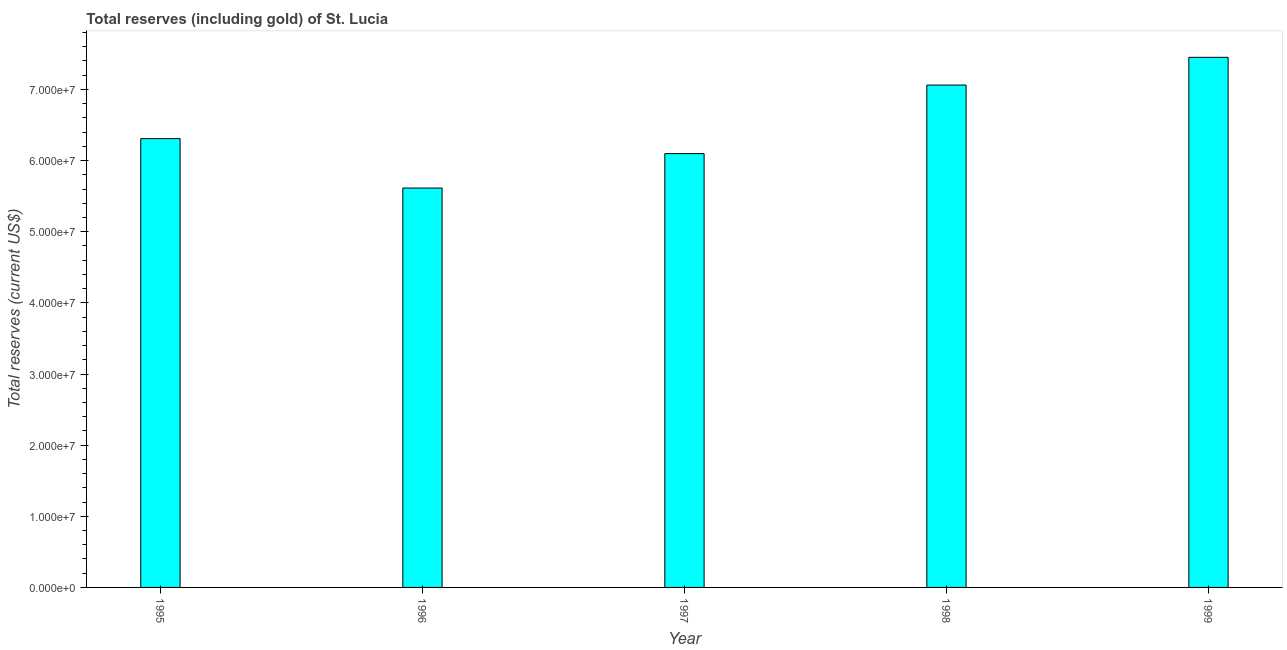Does the graph contain grids?
Provide a short and direct response. No. What is the title of the graph?
Give a very brief answer. Total reserves (including gold) of St. Lucia. What is the label or title of the X-axis?
Keep it short and to the point. Year. What is the label or title of the Y-axis?
Your answer should be very brief. Total reserves (current US$). What is the total reserves (including gold) in 1997?
Offer a very short reply. 6.10e+07. Across all years, what is the maximum total reserves (including gold)?
Your answer should be very brief. 7.45e+07. Across all years, what is the minimum total reserves (including gold)?
Ensure brevity in your answer.  5.61e+07. In which year was the total reserves (including gold) maximum?
Provide a succinct answer. 1999. In which year was the total reserves (including gold) minimum?
Provide a short and direct response. 1996. What is the sum of the total reserves (including gold)?
Your response must be concise. 3.25e+08. What is the difference between the total reserves (including gold) in 1996 and 1997?
Make the answer very short. -4.84e+06. What is the average total reserves (including gold) per year?
Your answer should be very brief. 6.51e+07. What is the median total reserves (including gold)?
Give a very brief answer. 6.31e+07. Do a majority of the years between 1995 and 1997 (inclusive) have total reserves (including gold) greater than 44000000 US$?
Offer a terse response. Yes. What is the ratio of the total reserves (including gold) in 1997 to that in 1998?
Your answer should be compact. 0.86. Is the total reserves (including gold) in 1998 less than that in 1999?
Give a very brief answer. Yes. What is the difference between the highest and the second highest total reserves (including gold)?
Your answer should be compact. 3.90e+06. What is the difference between the highest and the lowest total reserves (including gold)?
Provide a short and direct response. 1.84e+07. In how many years, is the total reserves (including gold) greater than the average total reserves (including gold) taken over all years?
Your response must be concise. 2. How many bars are there?
Provide a short and direct response. 5. Are all the bars in the graph horizontal?
Your response must be concise. No. How many years are there in the graph?
Your answer should be compact. 5. What is the difference between two consecutive major ticks on the Y-axis?
Ensure brevity in your answer.  1.00e+07. Are the values on the major ticks of Y-axis written in scientific E-notation?
Your response must be concise. Yes. What is the Total reserves (current US$) in 1995?
Keep it short and to the point. 6.31e+07. What is the Total reserves (current US$) of 1996?
Offer a terse response. 5.61e+07. What is the Total reserves (current US$) in 1997?
Make the answer very short. 6.10e+07. What is the Total reserves (current US$) of 1998?
Make the answer very short. 7.06e+07. What is the Total reserves (current US$) of 1999?
Your response must be concise. 7.45e+07. What is the difference between the Total reserves (current US$) in 1995 and 1996?
Give a very brief answer. 6.95e+06. What is the difference between the Total reserves (current US$) in 1995 and 1997?
Keep it short and to the point. 2.11e+06. What is the difference between the Total reserves (current US$) in 1995 and 1998?
Your answer should be compact. -7.52e+06. What is the difference between the Total reserves (current US$) in 1995 and 1999?
Your response must be concise. -1.14e+07. What is the difference between the Total reserves (current US$) in 1996 and 1997?
Give a very brief answer. -4.84e+06. What is the difference between the Total reserves (current US$) in 1996 and 1998?
Your answer should be very brief. -1.45e+07. What is the difference between the Total reserves (current US$) in 1996 and 1999?
Your answer should be very brief. -1.84e+07. What is the difference between the Total reserves (current US$) in 1997 and 1998?
Provide a succinct answer. -9.63e+06. What is the difference between the Total reserves (current US$) in 1997 and 1999?
Make the answer very short. -1.35e+07. What is the difference between the Total reserves (current US$) in 1998 and 1999?
Your answer should be very brief. -3.90e+06. What is the ratio of the Total reserves (current US$) in 1995 to that in 1996?
Keep it short and to the point. 1.12. What is the ratio of the Total reserves (current US$) in 1995 to that in 1997?
Your answer should be very brief. 1.03. What is the ratio of the Total reserves (current US$) in 1995 to that in 1998?
Your response must be concise. 0.89. What is the ratio of the Total reserves (current US$) in 1995 to that in 1999?
Your answer should be compact. 0.85. What is the ratio of the Total reserves (current US$) in 1996 to that in 1997?
Provide a succinct answer. 0.92. What is the ratio of the Total reserves (current US$) in 1996 to that in 1998?
Provide a succinct answer. 0.8. What is the ratio of the Total reserves (current US$) in 1996 to that in 1999?
Offer a terse response. 0.75. What is the ratio of the Total reserves (current US$) in 1997 to that in 1998?
Ensure brevity in your answer.  0.86. What is the ratio of the Total reserves (current US$) in 1997 to that in 1999?
Provide a short and direct response. 0.82. What is the ratio of the Total reserves (current US$) in 1998 to that in 1999?
Provide a succinct answer. 0.95. 